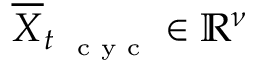Convert formula to latex. <formula><loc_0><loc_0><loc_500><loc_500>\overline { \boldsymbol X } _ { t _ { c y c } } \in \mathbb { R } ^ { \boldsymbol \nu }</formula> 